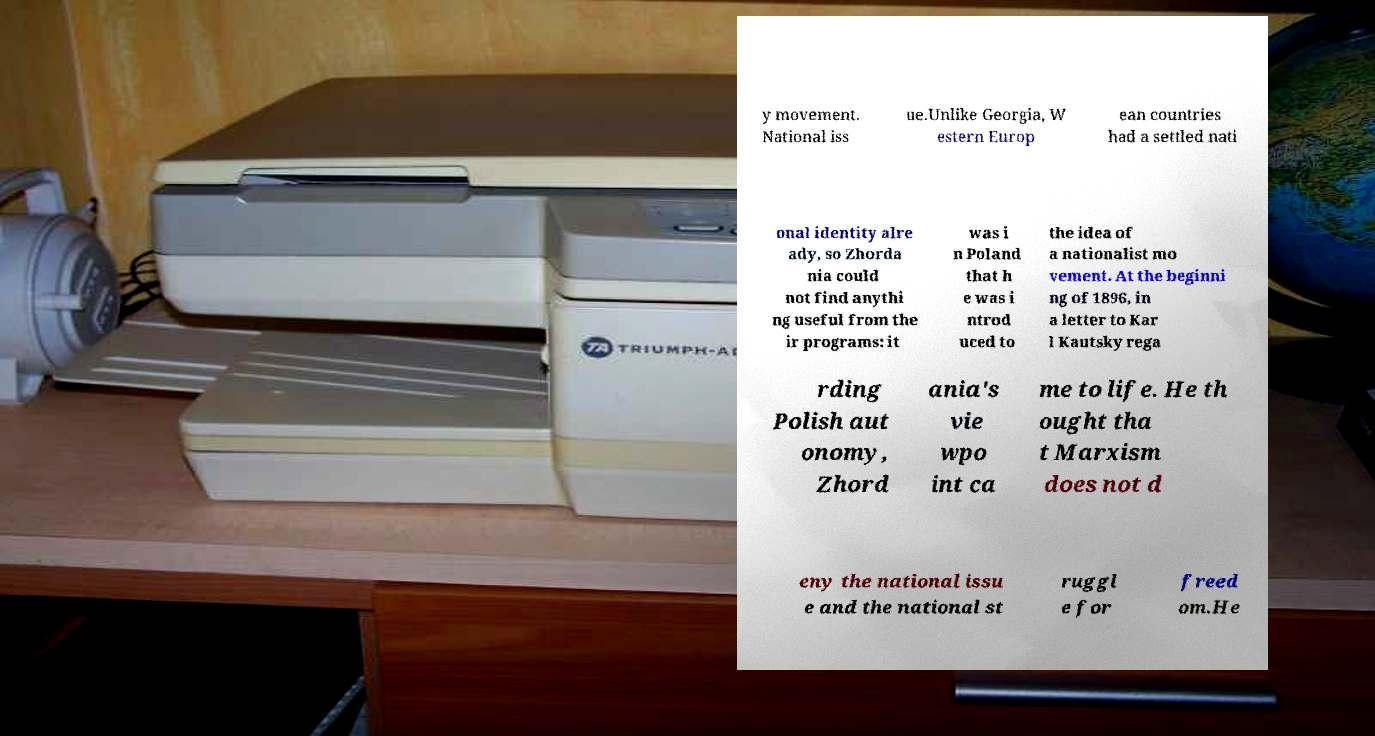Could you extract and type out the text from this image? y movement. National iss ue.Unlike Georgia, W estern Europ ean countries had a settled nati onal identity alre ady, so Zhorda nia could not find anythi ng useful from the ir programs: it was i n Poland that h e was i ntrod uced to the idea of a nationalist mo vement. At the beginni ng of 1896, in a letter to Kar l Kautsky rega rding Polish aut onomy, Zhord ania's vie wpo int ca me to life. He th ought tha t Marxism does not d eny the national issu e and the national st ruggl e for freed om.He 